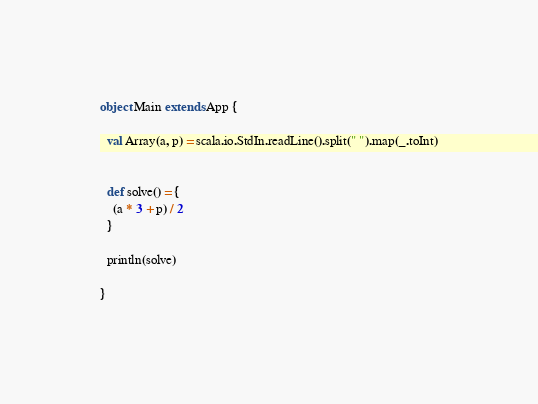Convert code to text. <code><loc_0><loc_0><loc_500><loc_500><_Scala_>
object Main extends App {

  val Array(a, p) = scala.io.StdIn.readLine().split(" ").map(_.toInt)


  def solve() = {
    (a * 3 + p) / 2
  }

  println(solve)

}
</code> 